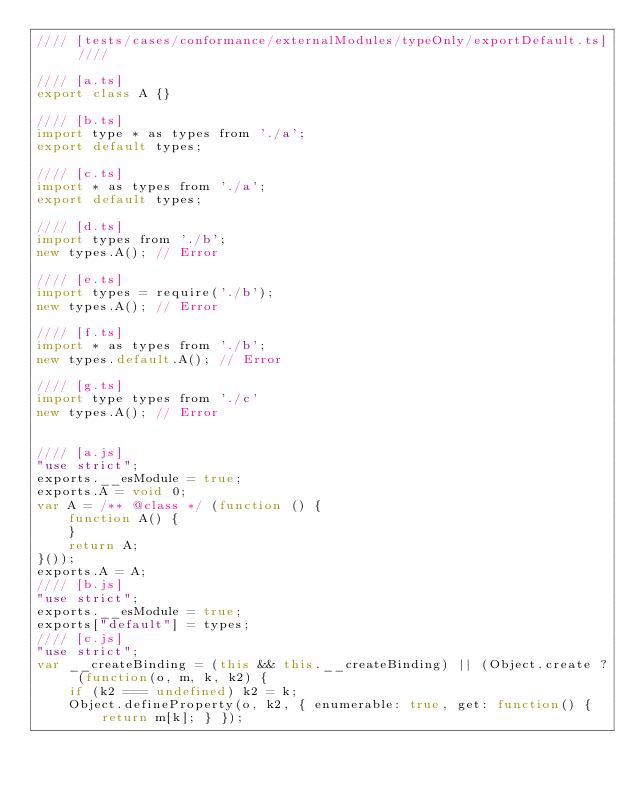Convert code to text. <code><loc_0><loc_0><loc_500><loc_500><_JavaScript_>//// [tests/cases/conformance/externalModules/typeOnly/exportDefault.ts] ////

//// [a.ts]
export class A {}

//// [b.ts]
import type * as types from './a';
export default types;

//// [c.ts]
import * as types from './a';
export default types;

//// [d.ts]
import types from './b';
new types.A(); // Error

//// [e.ts]
import types = require('./b');
new types.A(); // Error

//// [f.ts]
import * as types from './b';
new types.default.A(); // Error

//// [g.ts]
import type types from './c'
new types.A(); // Error


//// [a.js]
"use strict";
exports.__esModule = true;
exports.A = void 0;
var A = /** @class */ (function () {
    function A() {
    }
    return A;
}());
exports.A = A;
//// [b.js]
"use strict";
exports.__esModule = true;
exports["default"] = types;
//// [c.js]
"use strict";
var __createBinding = (this && this.__createBinding) || (Object.create ? (function(o, m, k, k2) {
    if (k2 === undefined) k2 = k;
    Object.defineProperty(o, k2, { enumerable: true, get: function() { return m[k]; } });</code> 